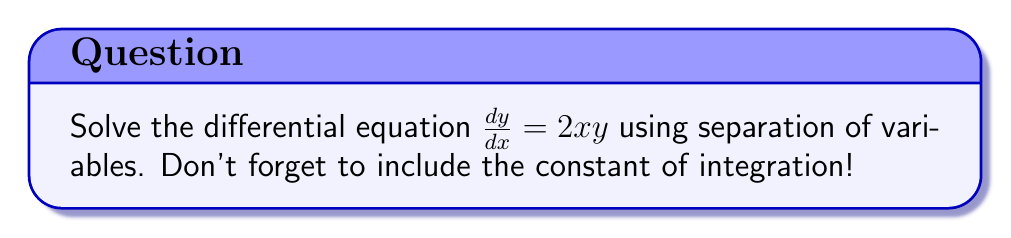What is the answer to this math problem? Okay, let's solve this step-by-step:

1) First, we need to separate the variables. We'll move all y terms to one side and all x terms to the other:

   $\frac{1}{y} dy = 2x dx$

2) Now, we integrate both sides:

   $\int \frac{1}{y} dy = \int 2x dx$

3) The left side integrates to $\ln|y|$, and the right side integrates to $x^2$. Don't forget the constant of integration!

   $\ln|y| = x^2 + C$

4) To solve for y, we need to apply the exponential function to both sides:

   $e^{\ln|y|} = e^{x^2 + C}$

5) The left side simplifies to just $|y|$:

   $|y| = e^{x^2 + C}$

6) We can rewrite this as:

   $|y| = e^{x^2} \cdot e^C$

7) Since $e^C$ is just some constant, we can replace it with a new constant $A$:

   $|y| = Ae^{x^2}$

8) Finally, we can remove the absolute value signs by allowing $A$ to be positive or negative:

   $y = Ae^{x^2}$

Where $A$ is an arbitrary non-zero constant.
Answer: $y = Ae^{x^2}$, where $A$ is a non-zero constant 